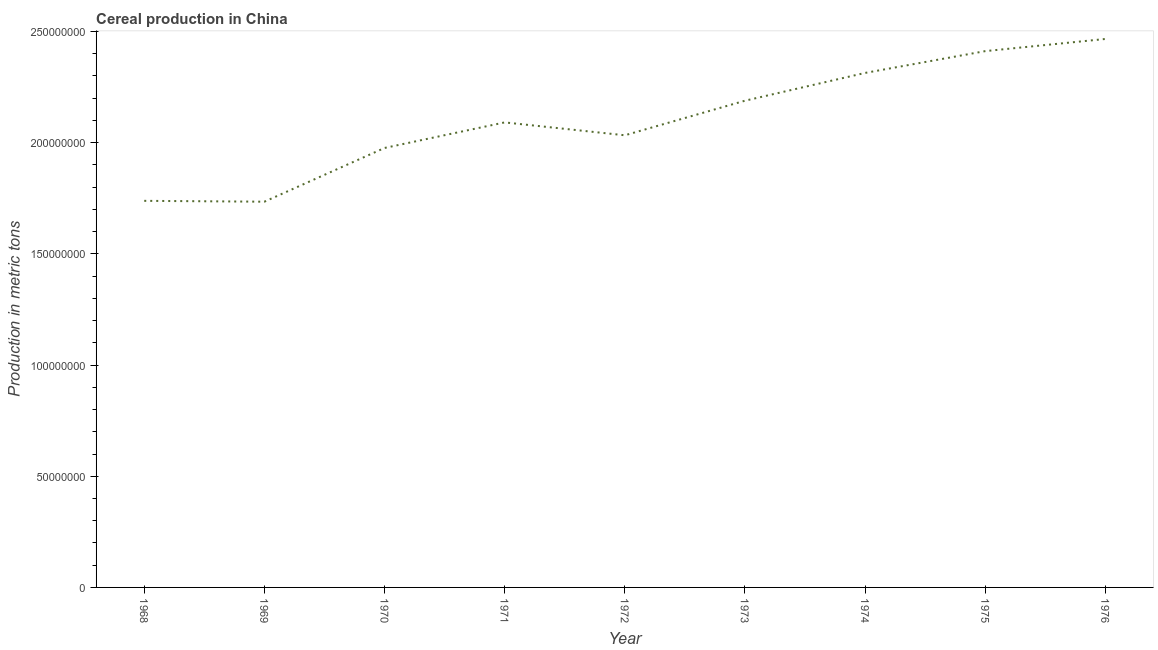What is the cereal production in 1970?
Keep it short and to the point. 1.98e+08. Across all years, what is the maximum cereal production?
Ensure brevity in your answer.  2.47e+08. Across all years, what is the minimum cereal production?
Provide a short and direct response. 1.73e+08. In which year was the cereal production maximum?
Provide a short and direct response. 1976. In which year was the cereal production minimum?
Make the answer very short. 1969. What is the sum of the cereal production?
Your response must be concise. 1.90e+09. What is the difference between the cereal production in 1972 and 1975?
Make the answer very short. -3.79e+07. What is the average cereal production per year?
Keep it short and to the point. 2.11e+08. What is the median cereal production?
Make the answer very short. 2.09e+08. In how many years, is the cereal production greater than 150000000 metric tons?
Your answer should be very brief. 9. Do a majority of the years between 1972 and 1976 (inclusive) have cereal production greater than 100000000 metric tons?
Your answer should be very brief. Yes. What is the ratio of the cereal production in 1973 to that in 1974?
Your response must be concise. 0.95. Is the difference between the cereal production in 1973 and 1976 greater than the difference between any two years?
Ensure brevity in your answer.  No. What is the difference between the highest and the second highest cereal production?
Give a very brief answer. 5.46e+06. What is the difference between the highest and the lowest cereal production?
Provide a short and direct response. 7.32e+07. In how many years, is the cereal production greater than the average cereal production taken over all years?
Provide a succinct answer. 4. Does the cereal production monotonically increase over the years?
Give a very brief answer. No. How many lines are there?
Provide a short and direct response. 1. How many years are there in the graph?
Provide a succinct answer. 9. Does the graph contain any zero values?
Your response must be concise. No. Does the graph contain grids?
Ensure brevity in your answer.  No. What is the title of the graph?
Offer a terse response. Cereal production in China. What is the label or title of the Y-axis?
Make the answer very short. Production in metric tons. What is the Production in metric tons of 1968?
Your answer should be compact. 1.74e+08. What is the Production in metric tons in 1969?
Ensure brevity in your answer.  1.73e+08. What is the Production in metric tons of 1970?
Offer a very short reply. 1.98e+08. What is the Production in metric tons in 1971?
Your response must be concise. 2.09e+08. What is the Production in metric tons in 1972?
Your response must be concise. 2.03e+08. What is the Production in metric tons in 1973?
Ensure brevity in your answer.  2.19e+08. What is the Production in metric tons of 1974?
Ensure brevity in your answer.  2.31e+08. What is the Production in metric tons of 1975?
Give a very brief answer. 2.41e+08. What is the Production in metric tons of 1976?
Provide a succinct answer. 2.47e+08. What is the difference between the Production in metric tons in 1968 and 1969?
Give a very brief answer. 3.85e+05. What is the difference between the Production in metric tons in 1968 and 1970?
Make the answer very short. -2.38e+07. What is the difference between the Production in metric tons in 1968 and 1971?
Provide a short and direct response. -3.53e+07. What is the difference between the Production in metric tons in 1968 and 1972?
Your answer should be very brief. -2.95e+07. What is the difference between the Production in metric tons in 1968 and 1973?
Your answer should be compact. -4.50e+07. What is the difference between the Production in metric tons in 1968 and 1974?
Make the answer very short. -5.75e+07. What is the difference between the Production in metric tons in 1968 and 1975?
Offer a terse response. -6.73e+07. What is the difference between the Production in metric tons in 1968 and 1976?
Offer a very short reply. -7.28e+07. What is the difference between the Production in metric tons in 1969 and 1970?
Make the answer very short. -2.42e+07. What is the difference between the Production in metric tons in 1969 and 1971?
Offer a terse response. -3.57e+07. What is the difference between the Production in metric tons in 1969 and 1972?
Provide a succinct answer. -2.99e+07. What is the difference between the Production in metric tons in 1969 and 1973?
Your response must be concise. -4.54e+07. What is the difference between the Production in metric tons in 1969 and 1974?
Keep it short and to the point. -5.79e+07. What is the difference between the Production in metric tons in 1969 and 1975?
Give a very brief answer. -6.77e+07. What is the difference between the Production in metric tons in 1969 and 1976?
Your response must be concise. -7.32e+07. What is the difference between the Production in metric tons in 1970 and 1971?
Make the answer very short. -1.15e+07. What is the difference between the Production in metric tons in 1970 and 1972?
Provide a succinct answer. -5.71e+06. What is the difference between the Production in metric tons in 1970 and 1973?
Offer a terse response. -2.13e+07. What is the difference between the Production in metric tons in 1970 and 1974?
Provide a succinct answer. -3.38e+07. What is the difference between the Production in metric tons in 1970 and 1975?
Ensure brevity in your answer.  -4.36e+07. What is the difference between the Production in metric tons in 1970 and 1976?
Your answer should be compact. -4.90e+07. What is the difference between the Production in metric tons in 1971 and 1972?
Make the answer very short. 5.79e+06. What is the difference between the Production in metric tons in 1971 and 1973?
Your response must be concise. -9.76e+06. What is the difference between the Production in metric tons in 1971 and 1974?
Offer a very short reply. -2.23e+07. What is the difference between the Production in metric tons in 1971 and 1975?
Make the answer very short. -3.21e+07. What is the difference between the Production in metric tons in 1971 and 1976?
Offer a very short reply. -3.75e+07. What is the difference between the Production in metric tons in 1972 and 1973?
Offer a terse response. -1.56e+07. What is the difference between the Production in metric tons in 1972 and 1974?
Your answer should be very brief. -2.80e+07. What is the difference between the Production in metric tons in 1972 and 1975?
Your response must be concise. -3.79e+07. What is the difference between the Production in metric tons in 1972 and 1976?
Provide a succinct answer. -4.33e+07. What is the difference between the Production in metric tons in 1973 and 1974?
Your answer should be compact. -1.25e+07. What is the difference between the Production in metric tons in 1973 and 1975?
Provide a succinct answer. -2.23e+07. What is the difference between the Production in metric tons in 1973 and 1976?
Offer a very short reply. -2.78e+07. What is the difference between the Production in metric tons in 1974 and 1975?
Your answer should be compact. -9.80e+06. What is the difference between the Production in metric tons in 1974 and 1976?
Keep it short and to the point. -1.53e+07. What is the difference between the Production in metric tons in 1975 and 1976?
Give a very brief answer. -5.46e+06. What is the ratio of the Production in metric tons in 1968 to that in 1969?
Offer a terse response. 1. What is the ratio of the Production in metric tons in 1968 to that in 1971?
Your answer should be compact. 0.83. What is the ratio of the Production in metric tons in 1968 to that in 1972?
Your response must be concise. 0.85. What is the ratio of the Production in metric tons in 1968 to that in 1973?
Your response must be concise. 0.79. What is the ratio of the Production in metric tons in 1968 to that in 1974?
Keep it short and to the point. 0.75. What is the ratio of the Production in metric tons in 1968 to that in 1975?
Give a very brief answer. 0.72. What is the ratio of the Production in metric tons in 1968 to that in 1976?
Make the answer very short. 0.7. What is the ratio of the Production in metric tons in 1969 to that in 1970?
Keep it short and to the point. 0.88. What is the ratio of the Production in metric tons in 1969 to that in 1971?
Offer a terse response. 0.83. What is the ratio of the Production in metric tons in 1969 to that in 1972?
Offer a very short reply. 0.85. What is the ratio of the Production in metric tons in 1969 to that in 1973?
Give a very brief answer. 0.79. What is the ratio of the Production in metric tons in 1969 to that in 1974?
Your answer should be compact. 0.75. What is the ratio of the Production in metric tons in 1969 to that in 1975?
Provide a succinct answer. 0.72. What is the ratio of the Production in metric tons in 1969 to that in 1976?
Provide a succinct answer. 0.7. What is the ratio of the Production in metric tons in 1970 to that in 1971?
Make the answer very short. 0.94. What is the ratio of the Production in metric tons in 1970 to that in 1973?
Your response must be concise. 0.9. What is the ratio of the Production in metric tons in 1970 to that in 1974?
Offer a terse response. 0.85. What is the ratio of the Production in metric tons in 1970 to that in 1975?
Keep it short and to the point. 0.82. What is the ratio of the Production in metric tons in 1970 to that in 1976?
Provide a succinct answer. 0.8. What is the ratio of the Production in metric tons in 1971 to that in 1972?
Your answer should be very brief. 1.03. What is the ratio of the Production in metric tons in 1971 to that in 1973?
Make the answer very short. 0.95. What is the ratio of the Production in metric tons in 1971 to that in 1974?
Offer a very short reply. 0.9. What is the ratio of the Production in metric tons in 1971 to that in 1975?
Give a very brief answer. 0.87. What is the ratio of the Production in metric tons in 1971 to that in 1976?
Your answer should be very brief. 0.85. What is the ratio of the Production in metric tons in 1972 to that in 1973?
Make the answer very short. 0.93. What is the ratio of the Production in metric tons in 1972 to that in 1974?
Ensure brevity in your answer.  0.88. What is the ratio of the Production in metric tons in 1972 to that in 1975?
Give a very brief answer. 0.84. What is the ratio of the Production in metric tons in 1972 to that in 1976?
Ensure brevity in your answer.  0.82. What is the ratio of the Production in metric tons in 1973 to that in 1974?
Your answer should be very brief. 0.95. What is the ratio of the Production in metric tons in 1973 to that in 1975?
Make the answer very short. 0.91. What is the ratio of the Production in metric tons in 1973 to that in 1976?
Your answer should be very brief. 0.89. What is the ratio of the Production in metric tons in 1974 to that in 1976?
Your response must be concise. 0.94. What is the ratio of the Production in metric tons in 1975 to that in 1976?
Offer a very short reply. 0.98. 